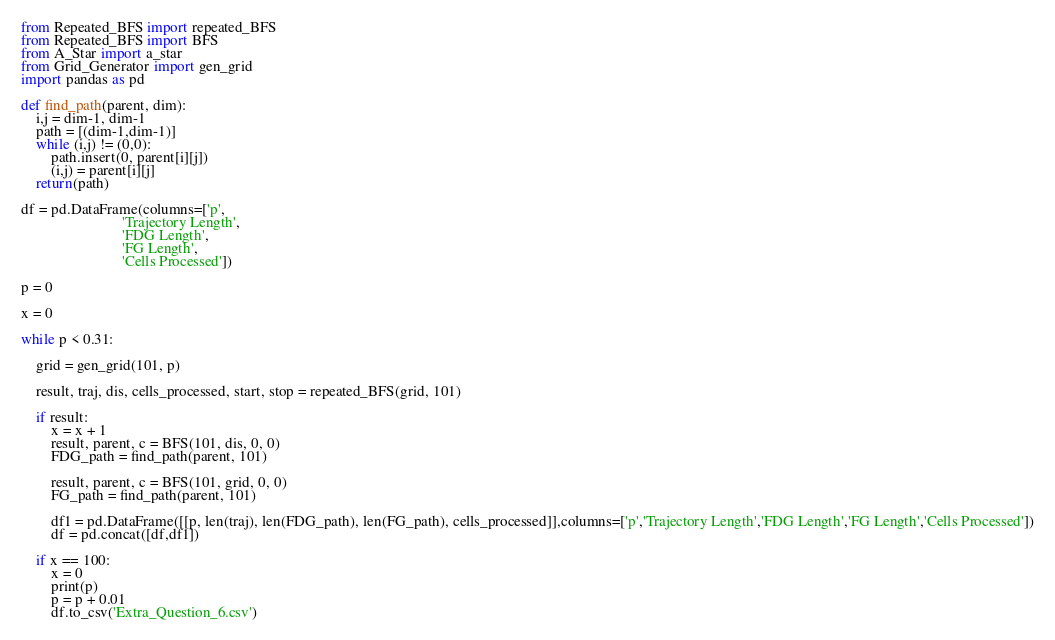<code> <loc_0><loc_0><loc_500><loc_500><_Python_>from Repeated_BFS import repeated_BFS
from Repeated_BFS import BFS
from A_Star import a_star
from Grid_Generator import gen_grid
import pandas as pd

def find_path(parent, dim):
    i,j = dim-1, dim-1
    path = [(dim-1,dim-1)]
    while (i,j) != (0,0):
        path.insert(0, parent[i][j])
        (i,j) = parent[i][j]
    return(path)

df = pd.DataFrame(columns=['p',
                           'Trajectory Length',
                           'FDG Length',
                           'FG Length',
                           'Cells Processed'])

p = 0

x = 0

while p < 0.31:
    
    grid = gen_grid(101, p)
    
    result, traj, dis, cells_processed, start, stop = repeated_BFS(grid, 101)
    
    if result:
        x = x + 1
        result, parent, c = BFS(101, dis, 0, 0)
        FDG_path = find_path(parent, 101)
        
        result, parent, c = BFS(101, grid, 0, 0)
        FG_path = find_path(parent, 101)
        
        df1 = pd.DataFrame([[p, len(traj), len(FDG_path), len(FG_path), cells_processed]],columns=['p','Trajectory Length','FDG Length','FG Length','Cells Processed'])
        df = pd.concat([df,df1])

    if x == 100:
        x = 0
        print(p)
        p = p + 0.01
        df.to_csv('Extra_Question_6.csv')
</code> 